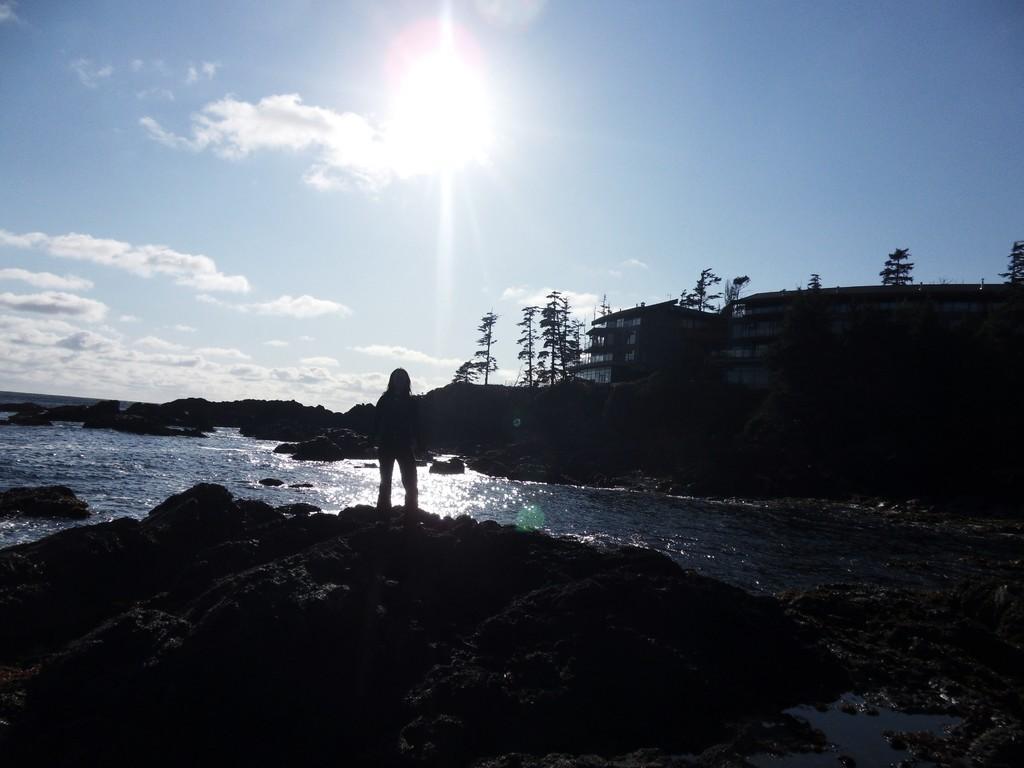How would you summarize this image in a sentence or two? In the image we can see a person standing. There is a building, there are many trees, water, stones, cloudy pale blue sky and the sun. 